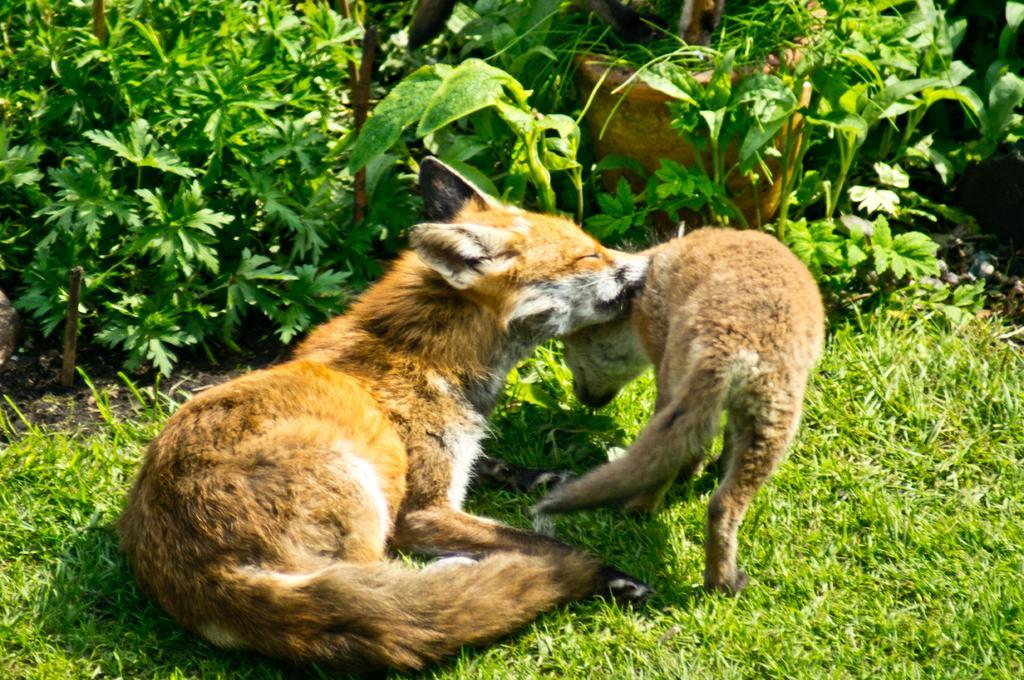How would you summarize this image in a sentence or two? There are two animals on the grasses. In the back there are plants and also there is a pot. 